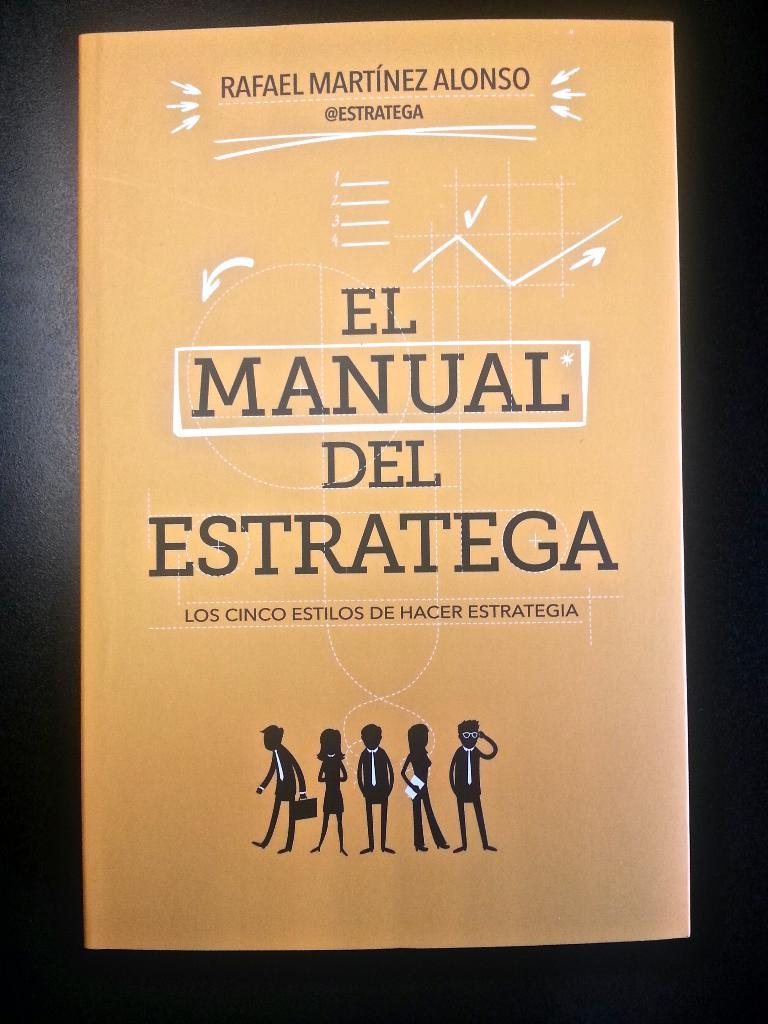<image>
Create a compact narrative representing the image presented. The cover of a book called "El Manual Del Estratega" by Rafael Martinez Alonso is shown on a dark background. 